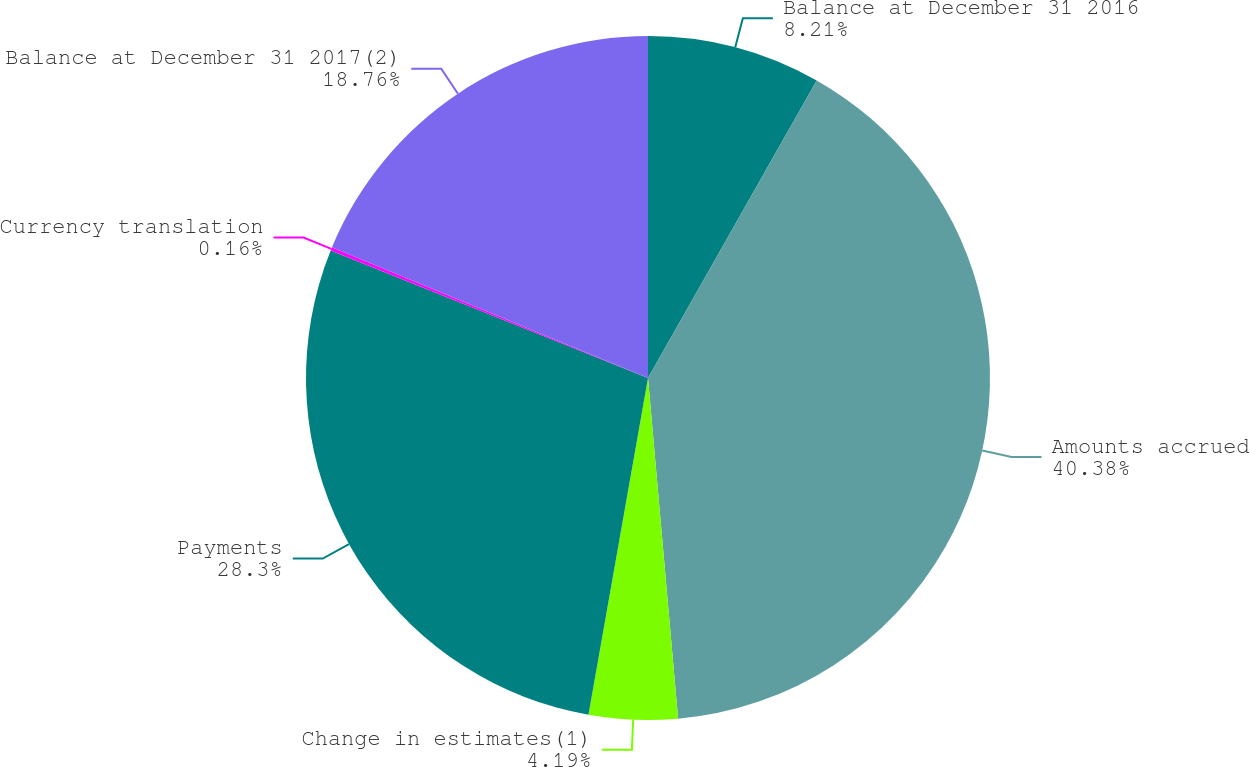<chart> <loc_0><loc_0><loc_500><loc_500><pie_chart><fcel>Balance at December 31 2016<fcel>Amounts accrued<fcel>Change in estimates(1)<fcel>Payments<fcel>Currency translation<fcel>Balance at December 31 2017(2)<nl><fcel>8.21%<fcel>40.39%<fcel>4.19%<fcel>28.3%<fcel>0.16%<fcel>18.76%<nl></chart> 